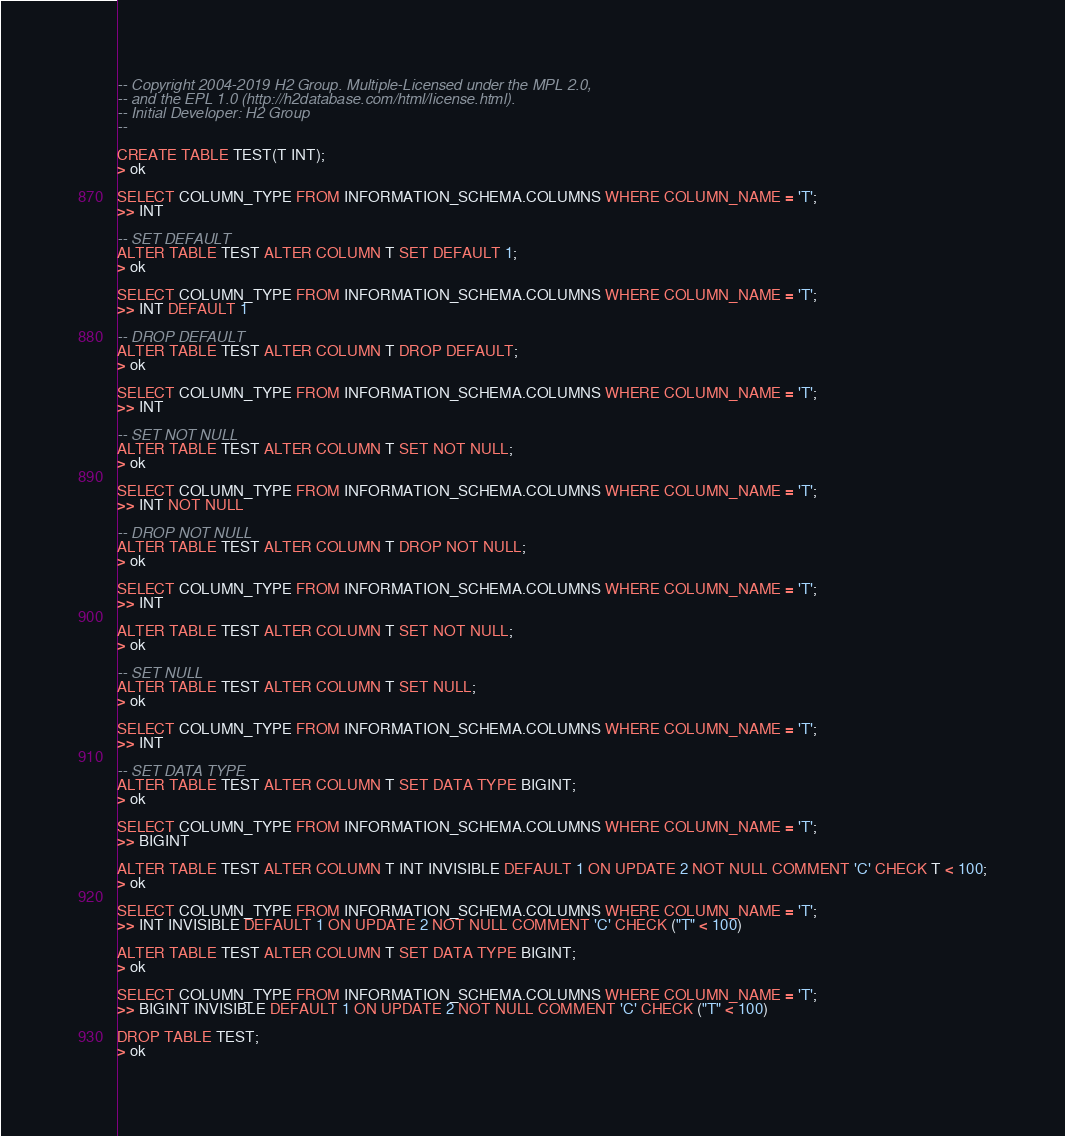Convert code to text. <code><loc_0><loc_0><loc_500><loc_500><_SQL_>-- Copyright 2004-2019 H2 Group. Multiple-Licensed under the MPL 2.0,
-- and the EPL 1.0 (http://h2database.com/html/license.html).
-- Initial Developer: H2 Group
--

CREATE TABLE TEST(T INT);
> ok

SELECT COLUMN_TYPE FROM INFORMATION_SCHEMA.COLUMNS WHERE COLUMN_NAME = 'T';
>> INT

-- SET DEFAULT
ALTER TABLE TEST ALTER COLUMN T SET DEFAULT 1;
> ok

SELECT COLUMN_TYPE FROM INFORMATION_SCHEMA.COLUMNS WHERE COLUMN_NAME = 'T';
>> INT DEFAULT 1

-- DROP DEFAULT
ALTER TABLE TEST ALTER COLUMN T DROP DEFAULT;
> ok

SELECT COLUMN_TYPE FROM INFORMATION_SCHEMA.COLUMNS WHERE COLUMN_NAME = 'T';
>> INT

-- SET NOT NULL
ALTER TABLE TEST ALTER COLUMN T SET NOT NULL;
> ok

SELECT COLUMN_TYPE FROM INFORMATION_SCHEMA.COLUMNS WHERE COLUMN_NAME = 'T';
>> INT NOT NULL

-- DROP NOT NULL
ALTER TABLE TEST ALTER COLUMN T DROP NOT NULL;
> ok

SELECT COLUMN_TYPE FROM INFORMATION_SCHEMA.COLUMNS WHERE COLUMN_NAME = 'T';
>> INT

ALTER TABLE TEST ALTER COLUMN T SET NOT NULL;
> ok

-- SET NULL
ALTER TABLE TEST ALTER COLUMN T SET NULL;
> ok

SELECT COLUMN_TYPE FROM INFORMATION_SCHEMA.COLUMNS WHERE COLUMN_NAME = 'T';
>> INT

-- SET DATA TYPE
ALTER TABLE TEST ALTER COLUMN T SET DATA TYPE BIGINT;
> ok

SELECT COLUMN_TYPE FROM INFORMATION_SCHEMA.COLUMNS WHERE COLUMN_NAME = 'T';
>> BIGINT

ALTER TABLE TEST ALTER COLUMN T INT INVISIBLE DEFAULT 1 ON UPDATE 2 NOT NULL COMMENT 'C' CHECK T < 100;
> ok

SELECT COLUMN_TYPE FROM INFORMATION_SCHEMA.COLUMNS WHERE COLUMN_NAME = 'T';
>> INT INVISIBLE DEFAULT 1 ON UPDATE 2 NOT NULL COMMENT 'C' CHECK ("T" < 100)

ALTER TABLE TEST ALTER COLUMN T SET DATA TYPE BIGINT;
> ok

SELECT COLUMN_TYPE FROM INFORMATION_SCHEMA.COLUMNS WHERE COLUMN_NAME = 'T';
>> BIGINT INVISIBLE DEFAULT 1 ON UPDATE 2 NOT NULL COMMENT 'C' CHECK ("T" < 100)

DROP TABLE TEST;
> ok
</code> 